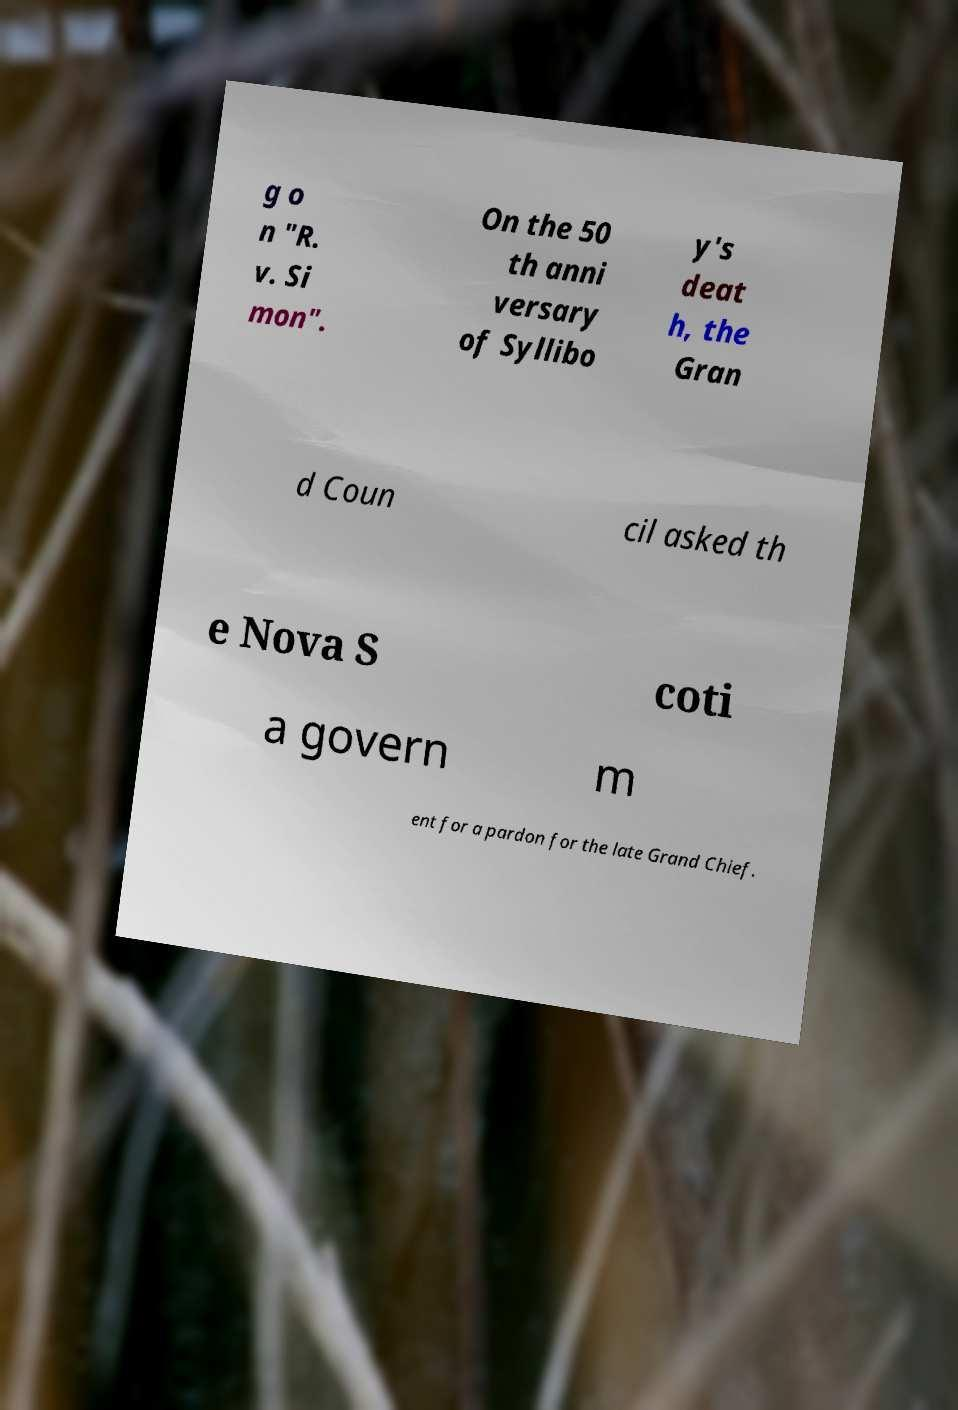I need the written content from this picture converted into text. Can you do that? g o n "R. v. Si mon". On the 50 th anni versary of Syllibo y's deat h, the Gran d Coun cil asked th e Nova S coti a govern m ent for a pardon for the late Grand Chief. 